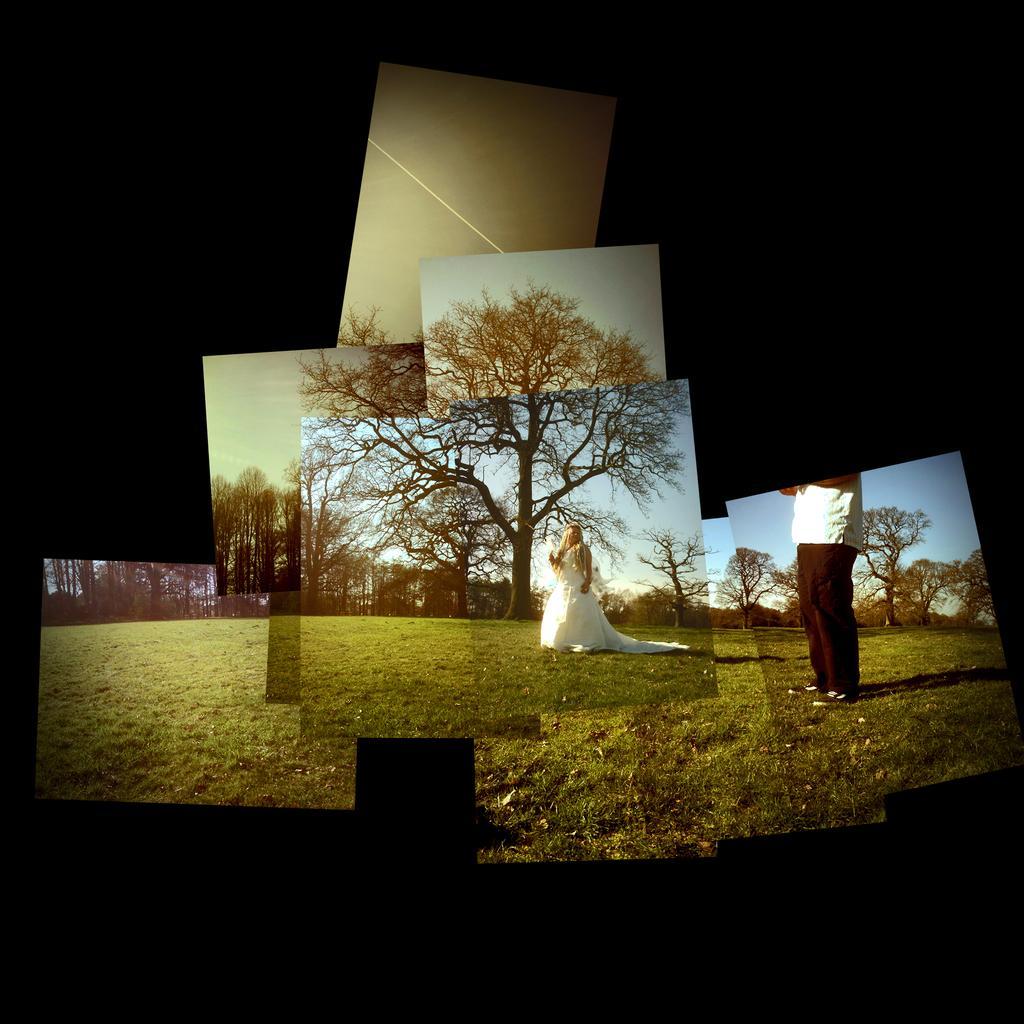Could you give a brief overview of what you see in this image? In this picture there are few images where there is a woman standing on a greenery ground and there is a person standing in the right corner and there are trees in the background. 